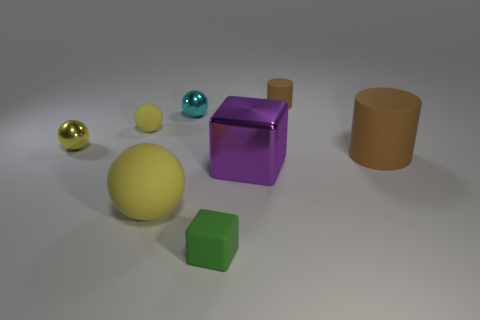Is the color of the sphere in front of the big brown object the same as the big cube?
Your response must be concise. No. There is a thing that is to the right of the small rubber cylinder; what number of big purple shiny blocks are behind it?
Keep it short and to the point. 0. What color is the cube that is the same size as the cyan sphere?
Your response must be concise. Green. What material is the cylinder that is in front of the tiny cylinder?
Provide a succinct answer. Rubber. The big object that is both to the right of the green rubber thing and on the left side of the tiny brown cylinder is made of what material?
Your answer should be very brief. Metal. There is a cube behind the green block; is its size the same as the big matte ball?
Offer a very short reply. Yes. There is a tiny green thing; what shape is it?
Keep it short and to the point. Cube. What number of small brown matte things have the same shape as the cyan thing?
Your answer should be compact. 0. How many things are behind the purple block and to the left of the small brown cylinder?
Your answer should be very brief. 3. The small block has what color?
Ensure brevity in your answer.  Green. 